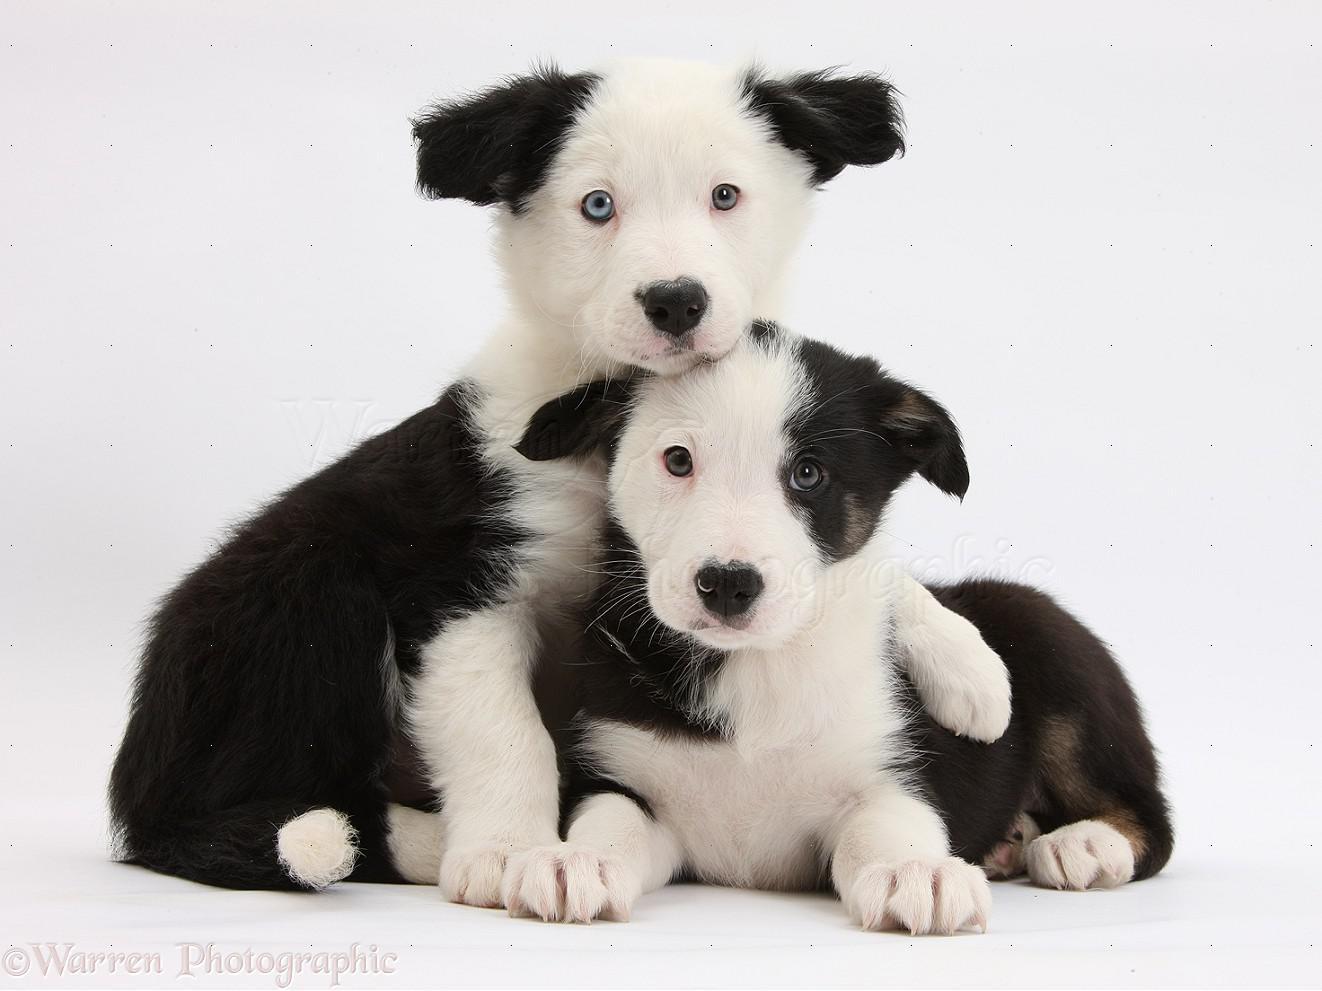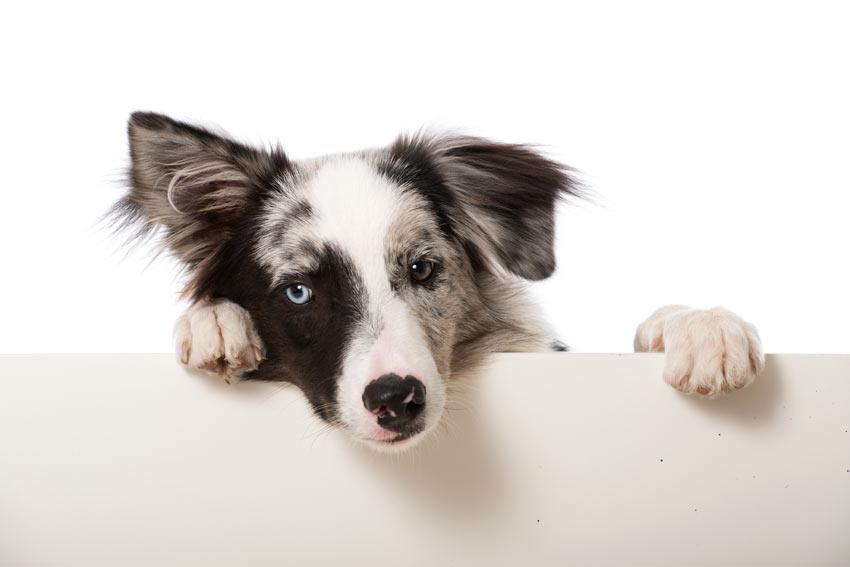The first image is the image on the left, the second image is the image on the right. Evaluate the accuracy of this statement regarding the images: "At least one of the dogs is standing up in the image on the right.". Is it true? Answer yes or no. No. The first image is the image on the left, the second image is the image on the right. Considering the images on both sides, is "There are at most four dogs." valid? Answer yes or no. Yes. 